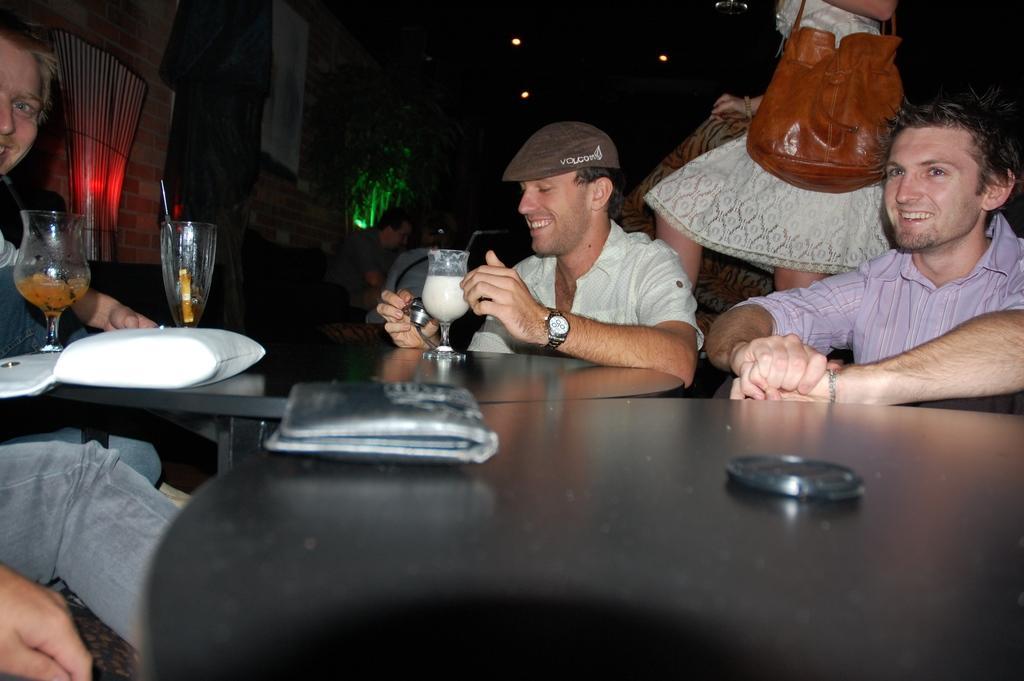In one or two sentences, can you explain what this image depicts? On the left hand side, there is a person sitting and laughing. In front him, there are two glasses on the table. On the right hand side, there are two persons sitting and laughing. One of them is looking at some object. In the background, there is a woman standing and holding a hand bag, some lights, trees, wall, some persons and other materials. 